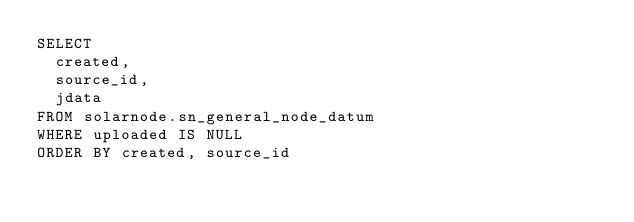<code> <loc_0><loc_0><loc_500><loc_500><_SQL_>SELECT 
	created,
	source_id,
	jdata
FROM solarnode.sn_general_node_datum
WHERE uploaded IS NULL
ORDER BY created, source_id
</code> 